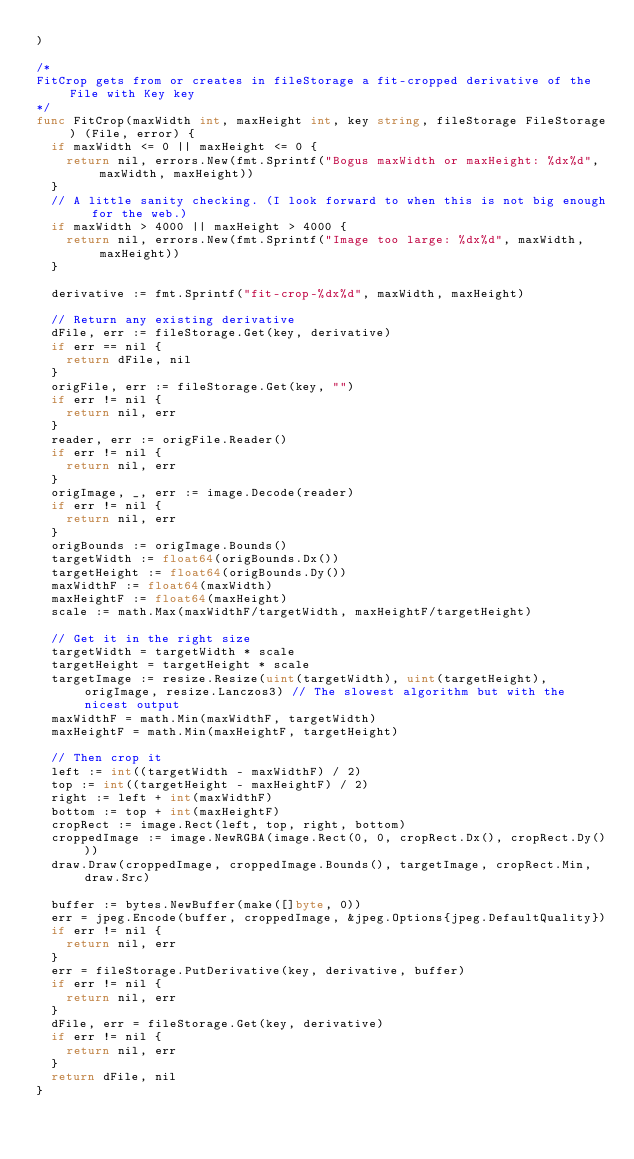Convert code to text. <code><loc_0><loc_0><loc_500><loc_500><_Go_>)

/*
FitCrop gets from or creates in fileStorage a fit-cropped derivative of the File with Key key
*/
func FitCrop(maxWidth int, maxHeight int, key string, fileStorage FileStorage) (File, error) {
	if maxWidth <= 0 || maxHeight <= 0 {
		return nil, errors.New(fmt.Sprintf("Bogus maxWidth or maxHeight: %dx%d", maxWidth, maxHeight))
	}
	// A little sanity checking. (I look forward to when this is not big enough for the web.)
	if maxWidth > 4000 || maxHeight > 4000 {
		return nil, errors.New(fmt.Sprintf("Image too large: %dx%d", maxWidth, maxHeight))
	}

	derivative := fmt.Sprintf("fit-crop-%dx%d", maxWidth, maxHeight)

	// Return any existing derivative
	dFile, err := fileStorage.Get(key, derivative)
	if err == nil {
		return dFile, nil
	}
	origFile, err := fileStorage.Get(key, "")
	if err != nil {
		return nil, err
	}
	reader, err := origFile.Reader()
	if err != nil {
		return nil, err
	}
	origImage, _, err := image.Decode(reader)
	if err != nil {
		return nil, err
	}
	origBounds := origImage.Bounds()
	targetWidth := float64(origBounds.Dx())
	targetHeight := float64(origBounds.Dy())
	maxWidthF := float64(maxWidth)
	maxHeightF := float64(maxHeight)
	scale := math.Max(maxWidthF/targetWidth, maxHeightF/targetHeight)

	// Get it in the right size
	targetWidth = targetWidth * scale
	targetHeight = targetHeight * scale
	targetImage := resize.Resize(uint(targetWidth), uint(targetHeight), origImage, resize.Lanczos3) // The slowest algorithm but with the nicest output
	maxWidthF = math.Min(maxWidthF, targetWidth)
	maxHeightF = math.Min(maxHeightF, targetHeight)

	// Then crop it
	left := int((targetWidth - maxWidthF) / 2)
	top := int((targetHeight - maxHeightF) / 2)
	right := left + int(maxWidthF)
	bottom := top + int(maxHeightF)
	cropRect := image.Rect(left, top, right, bottom)
	croppedImage := image.NewRGBA(image.Rect(0, 0, cropRect.Dx(), cropRect.Dy()))
	draw.Draw(croppedImage, croppedImage.Bounds(), targetImage, cropRect.Min, draw.Src)

	buffer := bytes.NewBuffer(make([]byte, 0))
	err = jpeg.Encode(buffer, croppedImage, &jpeg.Options{jpeg.DefaultQuality})
	if err != nil {
		return nil, err
	}
	err = fileStorage.PutDerivative(key, derivative, buffer)
	if err != nil {
		return nil, err
	}
	dFile, err = fileStorage.Get(key, derivative)
	if err != nil {
		return nil, err
	}
	return dFile, nil
}
</code> 